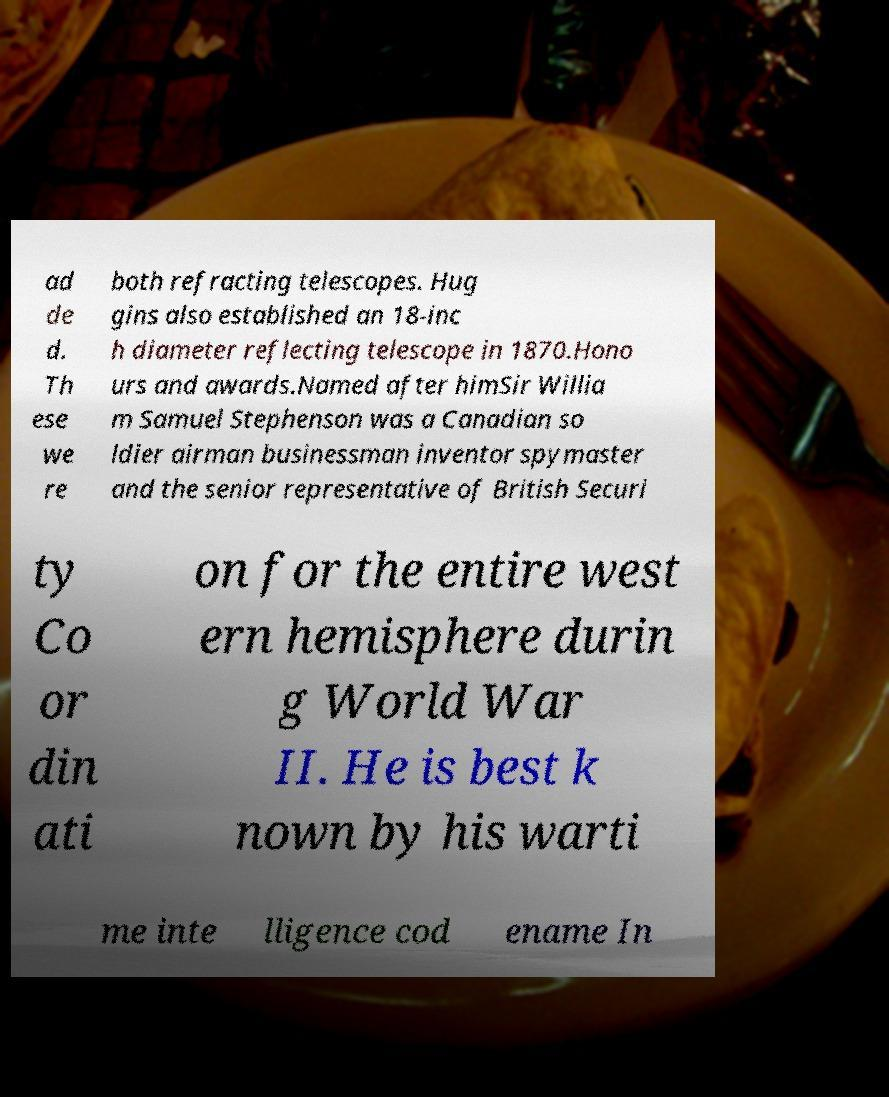Please read and relay the text visible in this image. What does it say? ad de d. Th ese we re both refracting telescopes. Hug gins also established an 18-inc h diameter reflecting telescope in 1870.Hono urs and awards.Named after himSir Willia m Samuel Stephenson was a Canadian so ldier airman businessman inventor spymaster and the senior representative of British Securi ty Co or din ati on for the entire west ern hemisphere durin g World War II. He is best k nown by his warti me inte lligence cod ename In 